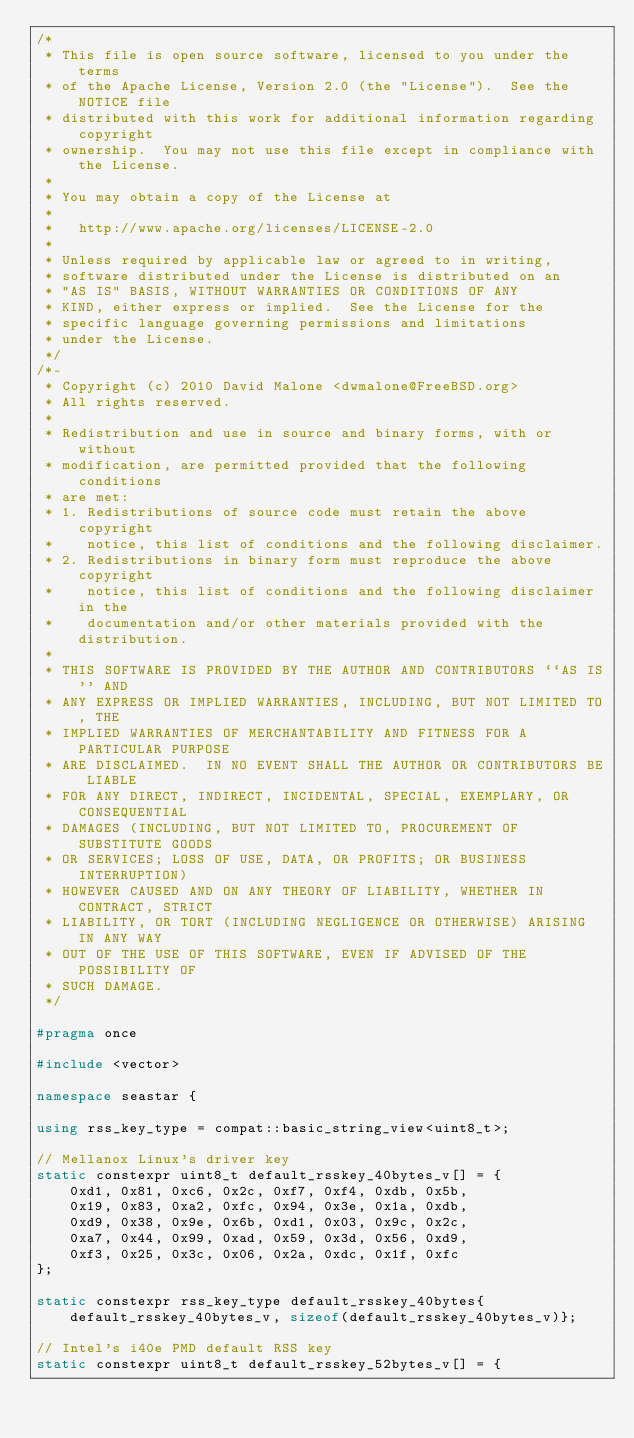Convert code to text. <code><loc_0><loc_0><loc_500><loc_500><_C++_>/*
 * This file is open source software, licensed to you under the terms
 * of the Apache License, Version 2.0 (the "License").  See the NOTICE file
 * distributed with this work for additional information regarding copyright
 * ownership.  You may not use this file except in compliance with the License.
 *
 * You may obtain a copy of the License at
 *
 *   http://www.apache.org/licenses/LICENSE-2.0
 *
 * Unless required by applicable law or agreed to in writing,
 * software distributed under the License is distributed on an
 * "AS IS" BASIS, WITHOUT WARRANTIES OR CONDITIONS OF ANY
 * KIND, either express or implied.  See the License for the
 * specific language governing permissions and limitations
 * under the License.
 */
/*-
 * Copyright (c) 2010 David Malone <dwmalone@FreeBSD.org>
 * All rights reserved.
 *
 * Redistribution and use in source and binary forms, with or without
 * modification, are permitted provided that the following conditions
 * are met:
 * 1. Redistributions of source code must retain the above copyright
 *    notice, this list of conditions and the following disclaimer.
 * 2. Redistributions in binary form must reproduce the above copyright
 *    notice, this list of conditions and the following disclaimer in the
 *    documentation and/or other materials provided with the distribution.
 *
 * THIS SOFTWARE IS PROVIDED BY THE AUTHOR AND CONTRIBUTORS ``AS IS'' AND
 * ANY EXPRESS OR IMPLIED WARRANTIES, INCLUDING, BUT NOT LIMITED TO, THE
 * IMPLIED WARRANTIES OF MERCHANTABILITY AND FITNESS FOR A PARTICULAR PURPOSE
 * ARE DISCLAIMED.  IN NO EVENT SHALL THE AUTHOR OR CONTRIBUTORS BE LIABLE
 * FOR ANY DIRECT, INDIRECT, INCIDENTAL, SPECIAL, EXEMPLARY, OR CONSEQUENTIAL
 * DAMAGES (INCLUDING, BUT NOT LIMITED TO, PROCUREMENT OF SUBSTITUTE GOODS
 * OR SERVICES; LOSS OF USE, DATA, OR PROFITS; OR BUSINESS INTERRUPTION)
 * HOWEVER CAUSED AND ON ANY THEORY OF LIABILITY, WHETHER IN CONTRACT, STRICT
 * LIABILITY, OR TORT (INCLUDING NEGLIGENCE OR OTHERWISE) ARISING IN ANY WAY
 * OUT OF THE USE OF THIS SOFTWARE, EVEN IF ADVISED OF THE POSSIBILITY OF
 * SUCH DAMAGE.
 */

#pragma once

#include <vector>

namespace seastar {

using rss_key_type = compat::basic_string_view<uint8_t>;

// Mellanox Linux's driver key
static constexpr uint8_t default_rsskey_40bytes_v[] = {
    0xd1, 0x81, 0xc6, 0x2c, 0xf7, 0xf4, 0xdb, 0x5b,
    0x19, 0x83, 0xa2, 0xfc, 0x94, 0x3e, 0x1a, 0xdb,
    0xd9, 0x38, 0x9e, 0x6b, 0xd1, 0x03, 0x9c, 0x2c,
    0xa7, 0x44, 0x99, 0xad, 0x59, 0x3d, 0x56, 0xd9,
    0xf3, 0x25, 0x3c, 0x06, 0x2a, 0xdc, 0x1f, 0xfc
};

static constexpr rss_key_type default_rsskey_40bytes{default_rsskey_40bytes_v, sizeof(default_rsskey_40bytes_v)};

// Intel's i40e PMD default RSS key
static constexpr uint8_t default_rsskey_52bytes_v[] = {</code> 